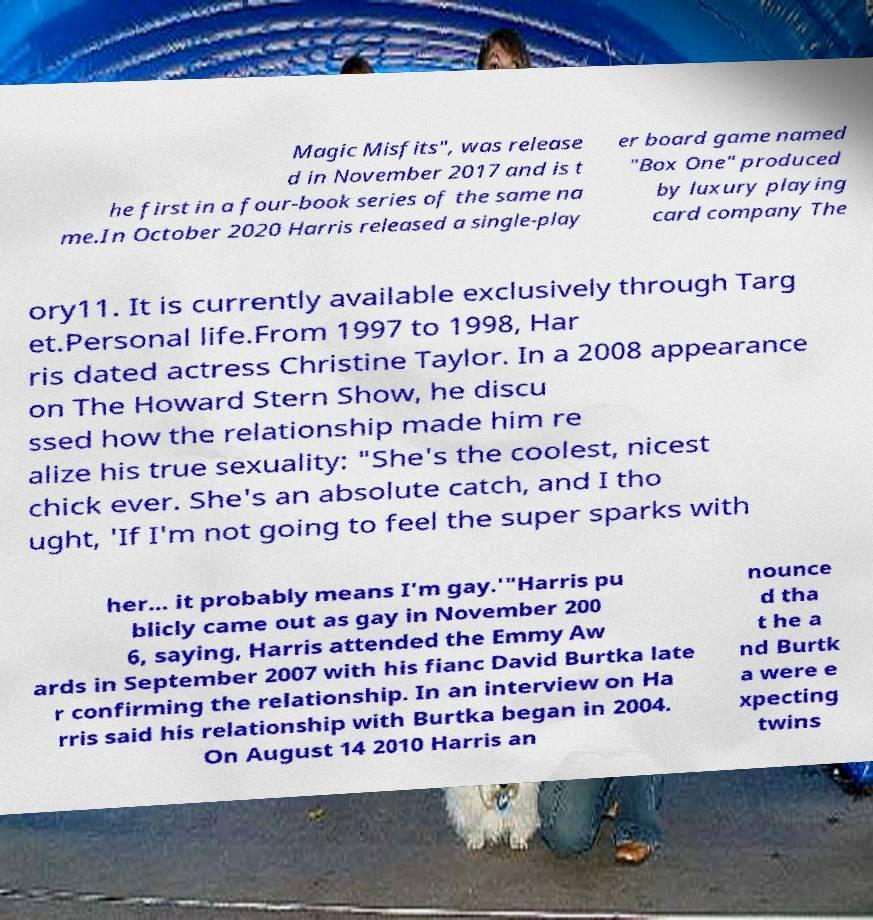There's text embedded in this image that I need extracted. Can you transcribe it verbatim? Magic Misfits", was release d in November 2017 and is t he first in a four-book series of the same na me.In October 2020 Harris released a single-play er board game named "Box One" produced by luxury playing card company The ory11. It is currently available exclusively through Targ et.Personal life.From 1997 to 1998, Har ris dated actress Christine Taylor. In a 2008 appearance on The Howard Stern Show, he discu ssed how the relationship made him re alize his true sexuality: "She's the coolest, nicest chick ever. She's an absolute catch, and I tho ught, 'If I'm not going to feel the super sparks with her... it probably means I'm gay.'"Harris pu blicly came out as gay in November 200 6, saying, Harris attended the Emmy Aw ards in September 2007 with his fianc David Burtka late r confirming the relationship. In an interview on Ha rris said his relationship with Burtka began in 2004. On August 14 2010 Harris an nounce d tha t he a nd Burtk a were e xpecting twins 